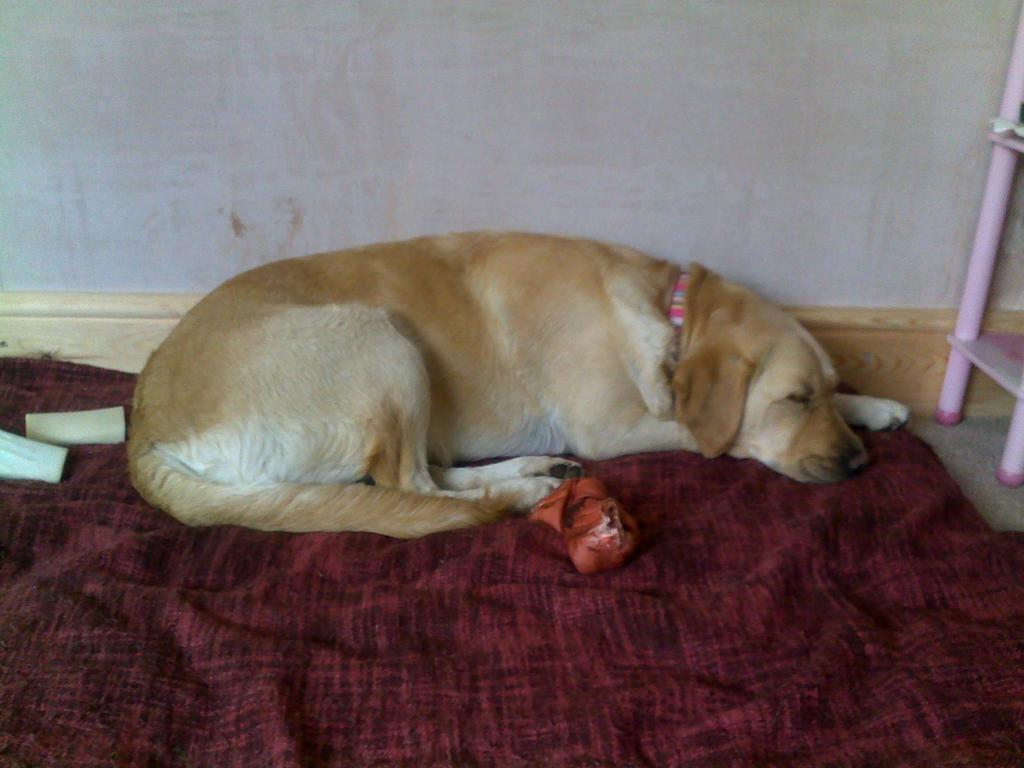What is the dog doing in the image? The dog is lying on the floor in the image. What else is on the floor besides the dog? There is a cloth on the floor. What color is the prominent object in the image? There is a red color thing in the image. What can be seen in the background of the image? There is a wall in the background. What is located on the right side of the image? There is a ladder on the right side of the image. How many cars are parked in front of the house in the image? There is no house or cars present in the image; it features a dog lying on the floor, a cloth, a red color thing, a wall in the background, and a ladder on the right side. 